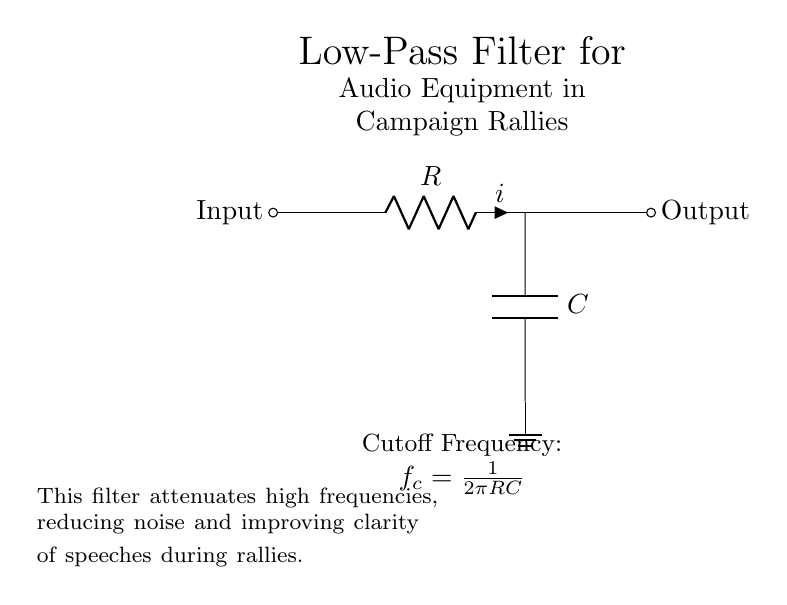What is the type of the first component in the circuit? The first component in the circuit is a resistor, which is indicated by the label R in the diagram.
Answer: Resistor What is the cutoff frequency formula for this filter? The formula for the cutoff frequency is given in the circuit as f_c = 1/(2πRC), meaning it employs the resistor (R) and the capacitor (C) values to determine it.
Answer: f_c = 1/(2πRC) What does the capacitor do in this circuit? The capacitor stores and releases electrical energy, allowing low frequencies to pass while attenuating higher frequencies, thus affecting the output signal's clarity.
Answer: Attenuates high frequencies What are the input and output labels in the circuit? The input and output of the circuit are labeled as "Input" and "Output," indicating the direction of the signal flow through the low-pass filter.
Answer: Input and Output How does adding resistance affect the cutoff frequency? Increasing resistance in the circuit will lower the cutoff frequency, as the cutoff frequency is inversely proportional to the resistance value, according to the formula provided.
Answer: Lower cutoff frequency What is the overall function of this low-pass filter? The low-pass filter is designed to reduce high-frequency noise and enhance speech clarity during rallies, as explained in the accompanying text of the diagram.
Answer: Reduce noise 